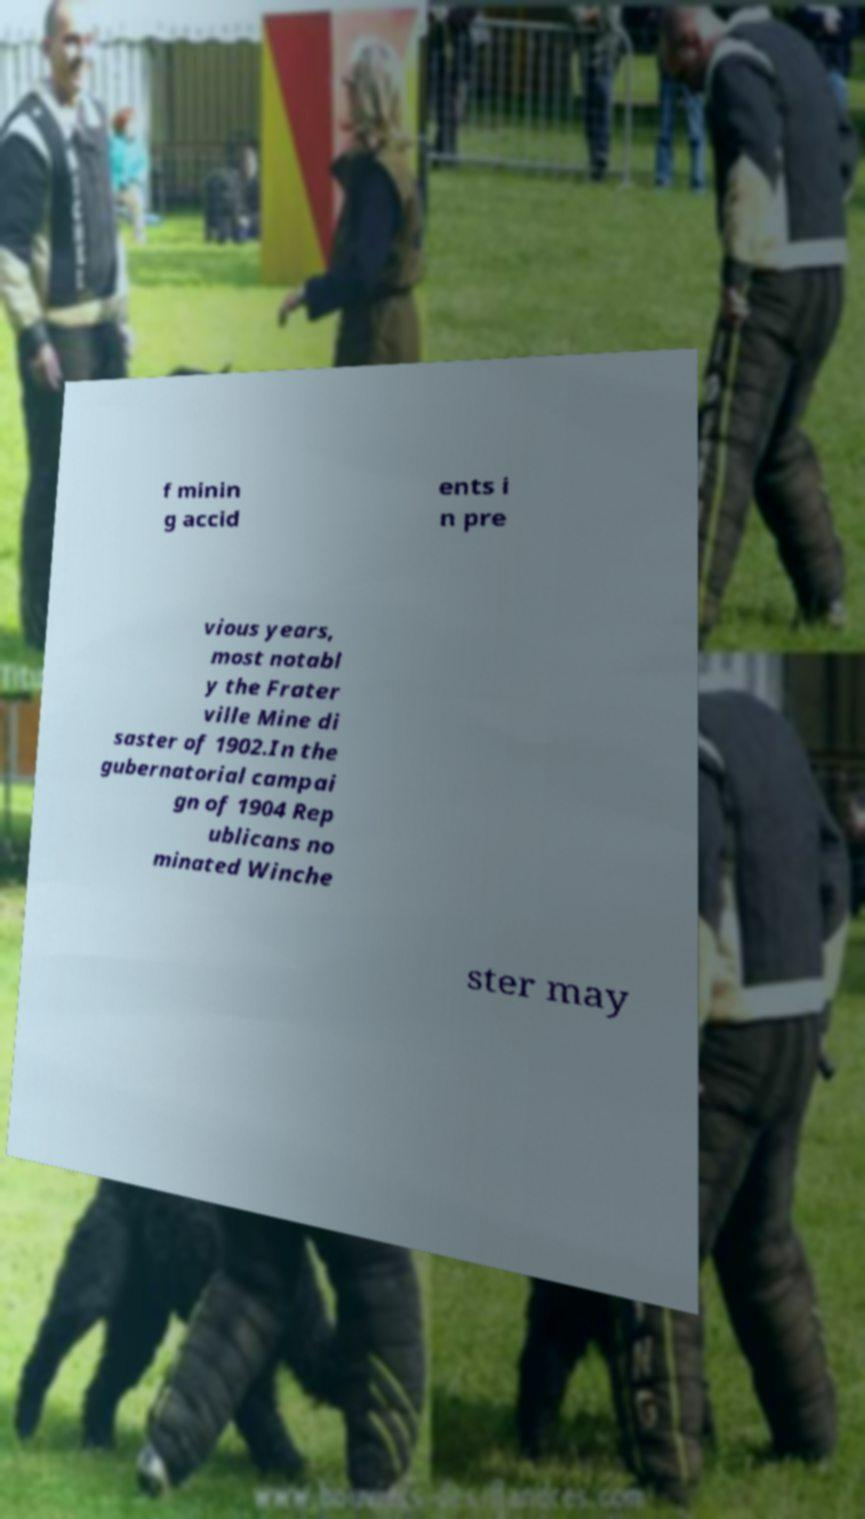I need the written content from this picture converted into text. Can you do that? f minin g accid ents i n pre vious years, most notabl y the Frater ville Mine di saster of 1902.In the gubernatorial campai gn of 1904 Rep ublicans no minated Winche ster may 